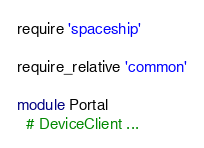Convert code to text. <code><loc_0><loc_0><loc_500><loc_500><_Ruby_>require 'spaceship'

require_relative 'common'

module Portal
  # DeviceClient ...</code> 